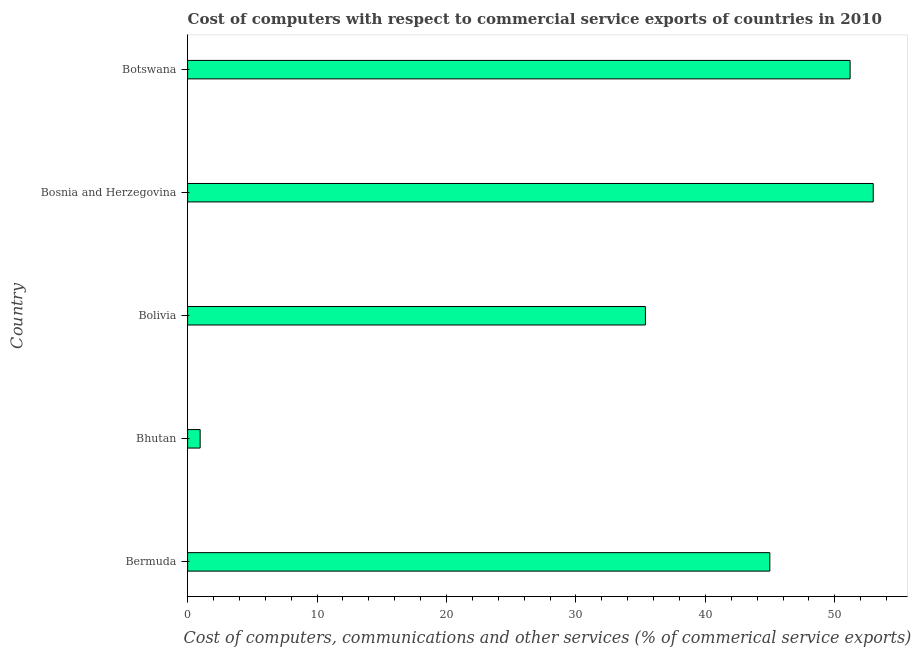Does the graph contain any zero values?
Offer a terse response. No. Does the graph contain grids?
Keep it short and to the point. No. What is the title of the graph?
Offer a very short reply. Cost of computers with respect to commercial service exports of countries in 2010. What is the label or title of the X-axis?
Offer a very short reply. Cost of computers, communications and other services (% of commerical service exports). What is the label or title of the Y-axis?
Ensure brevity in your answer.  Country. What is the  computer and other services in Bolivia?
Keep it short and to the point. 35.37. Across all countries, what is the maximum cost of communications?
Provide a short and direct response. 52.96. Across all countries, what is the minimum  computer and other services?
Provide a succinct answer. 0.97. In which country was the  computer and other services maximum?
Offer a terse response. Bosnia and Herzegovina. In which country was the cost of communications minimum?
Your response must be concise. Bhutan. What is the sum of the cost of communications?
Provide a succinct answer. 185.45. What is the difference between the cost of communications in Bhutan and Bolivia?
Your response must be concise. -34.4. What is the average cost of communications per country?
Give a very brief answer. 37.09. What is the median cost of communications?
Offer a terse response. 44.98. In how many countries, is the cost of communications greater than 4 %?
Give a very brief answer. 4. What is the ratio of the  computer and other services in Bolivia to that in Bosnia and Herzegovina?
Offer a terse response. 0.67. What is the difference between the highest and the second highest  computer and other services?
Provide a short and direct response. 1.78. What is the difference between the highest and the lowest cost of communications?
Provide a succinct answer. 52. In how many countries, is the  computer and other services greater than the average  computer and other services taken over all countries?
Your response must be concise. 3. How many countries are there in the graph?
Your answer should be very brief. 5. What is the Cost of computers, communications and other services (% of commerical service exports) of Bermuda?
Ensure brevity in your answer.  44.98. What is the Cost of computers, communications and other services (% of commerical service exports) in Bhutan?
Provide a short and direct response. 0.97. What is the Cost of computers, communications and other services (% of commerical service exports) of Bolivia?
Provide a short and direct response. 35.37. What is the Cost of computers, communications and other services (% of commerical service exports) of Bosnia and Herzegovina?
Make the answer very short. 52.96. What is the Cost of computers, communications and other services (% of commerical service exports) of Botswana?
Give a very brief answer. 51.18. What is the difference between the Cost of computers, communications and other services (% of commerical service exports) in Bermuda and Bhutan?
Provide a succinct answer. 44.01. What is the difference between the Cost of computers, communications and other services (% of commerical service exports) in Bermuda and Bolivia?
Offer a terse response. 9.61. What is the difference between the Cost of computers, communications and other services (% of commerical service exports) in Bermuda and Bosnia and Herzegovina?
Offer a very short reply. -7.99. What is the difference between the Cost of computers, communications and other services (% of commerical service exports) in Bermuda and Botswana?
Give a very brief answer. -6.2. What is the difference between the Cost of computers, communications and other services (% of commerical service exports) in Bhutan and Bolivia?
Give a very brief answer. -34.4. What is the difference between the Cost of computers, communications and other services (% of commerical service exports) in Bhutan and Bosnia and Herzegovina?
Provide a succinct answer. -52. What is the difference between the Cost of computers, communications and other services (% of commerical service exports) in Bhutan and Botswana?
Offer a terse response. -50.21. What is the difference between the Cost of computers, communications and other services (% of commerical service exports) in Bolivia and Bosnia and Herzegovina?
Provide a short and direct response. -17.6. What is the difference between the Cost of computers, communications and other services (% of commerical service exports) in Bolivia and Botswana?
Provide a succinct answer. -15.81. What is the difference between the Cost of computers, communications and other services (% of commerical service exports) in Bosnia and Herzegovina and Botswana?
Provide a short and direct response. 1.79. What is the ratio of the Cost of computers, communications and other services (% of commerical service exports) in Bermuda to that in Bhutan?
Keep it short and to the point. 46.44. What is the ratio of the Cost of computers, communications and other services (% of commerical service exports) in Bermuda to that in Bolivia?
Offer a very short reply. 1.27. What is the ratio of the Cost of computers, communications and other services (% of commerical service exports) in Bermuda to that in Bosnia and Herzegovina?
Ensure brevity in your answer.  0.85. What is the ratio of the Cost of computers, communications and other services (% of commerical service exports) in Bermuda to that in Botswana?
Provide a succinct answer. 0.88. What is the ratio of the Cost of computers, communications and other services (% of commerical service exports) in Bhutan to that in Bolivia?
Keep it short and to the point. 0.03. What is the ratio of the Cost of computers, communications and other services (% of commerical service exports) in Bhutan to that in Bosnia and Herzegovina?
Keep it short and to the point. 0.02. What is the ratio of the Cost of computers, communications and other services (% of commerical service exports) in Bhutan to that in Botswana?
Your answer should be compact. 0.02. What is the ratio of the Cost of computers, communications and other services (% of commerical service exports) in Bolivia to that in Bosnia and Herzegovina?
Your response must be concise. 0.67. What is the ratio of the Cost of computers, communications and other services (% of commerical service exports) in Bolivia to that in Botswana?
Ensure brevity in your answer.  0.69. What is the ratio of the Cost of computers, communications and other services (% of commerical service exports) in Bosnia and Herzegovina to that in Botswana?
Keep it short and to the point. 1.03. 